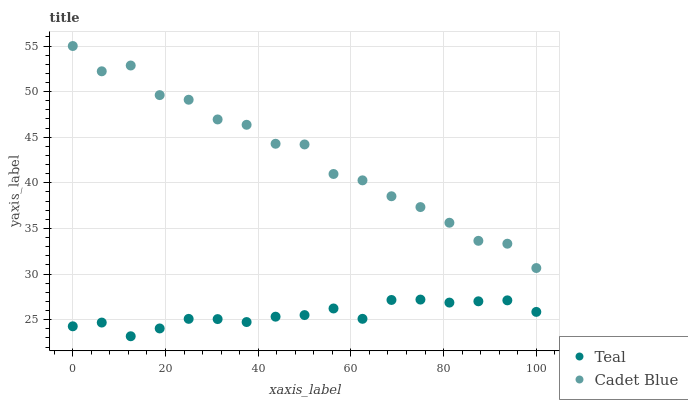Does Teal have the minimum area under the curve?
Answer yes or no. Yes. Does Cadet Blue have the maximum area under the curve?
Answer yes or no. Yes. Does Teal have the maximum area under the curve?
Answer yes or no. No. Is Teal the smoothest?
Answer yes or no. Yes. Is Cadet Blue the roughest?
Answer yes or no. Yes. Is Teal the roughest?
Answer yes or no. No. Does Teal have the lowest value?
Answer yes or no. Yes. Does Cadet Blue have the highest value?
Answer yes or no. Yes. Does Teal have the highest value?
Answer yes or no. No. Is Teal less than Cadet Blue?
Answer yes or no. Yes. Is Cadet Blue greater than Teal?
Answer yes or no. Yes. Does Teal intersect Cadet Blue?
Answer yes or no. No. 